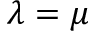<formula> <loc_0><loc_0><loc_500><loc_500>\lambda = \mu</formula> 